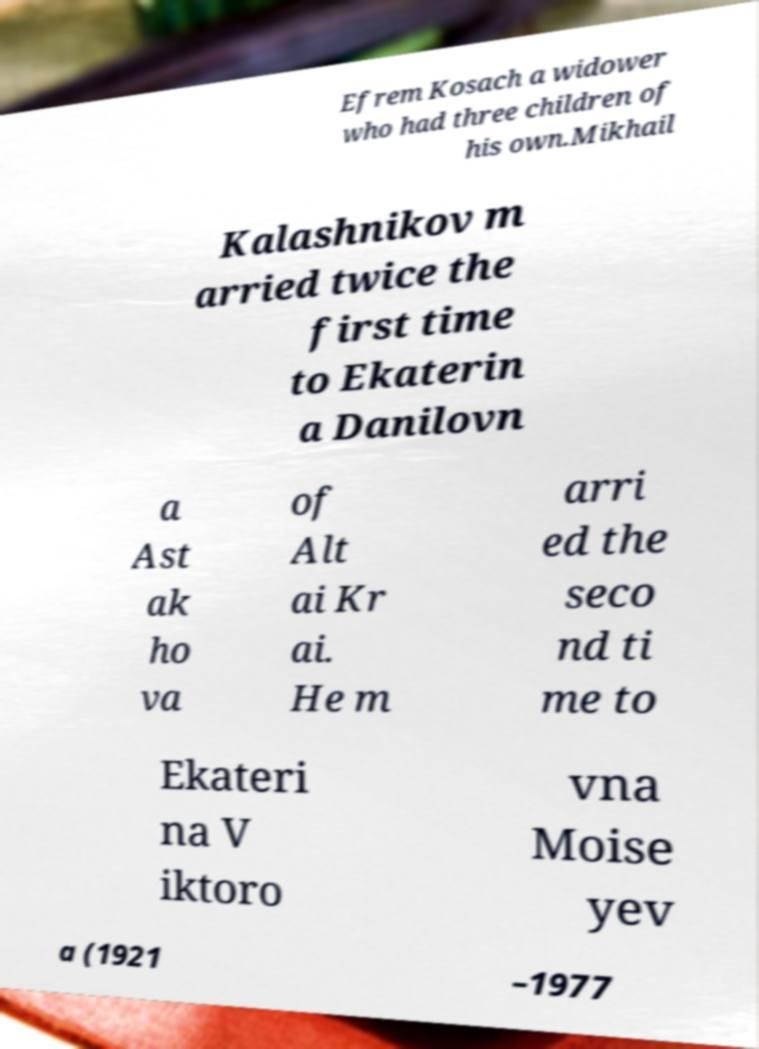Could you assist in decoding the text presented in this image and type it out clearly? Efrem Kosach a widower who had three children of his own.Mikhail Kalashnikov m arried twice the first time to Ekaterin a Danilovn a Ast ak ho va of Alt ai Kr ai. He m arri ed the seco nd ti me to Ekateri na V iktoro vna Moise yev a (1921 –1977 